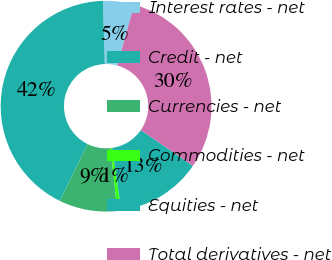Convert chart to OTSL. <chart><loc_0><loc_0><loc_500><loc_500><pie_chart><fcel>Interest rates - net<fcel>Credit - net<fcel>Currencies - net<fcel>Commodities - net<fcel>Equities - net<fcel>Total derivatives - net<nl><fcel>4.77%<fcel>42.28%<fcel>8.94%<fcel>0.61%<fcel>13.11%<fcel>30.28%<nl></chart> 